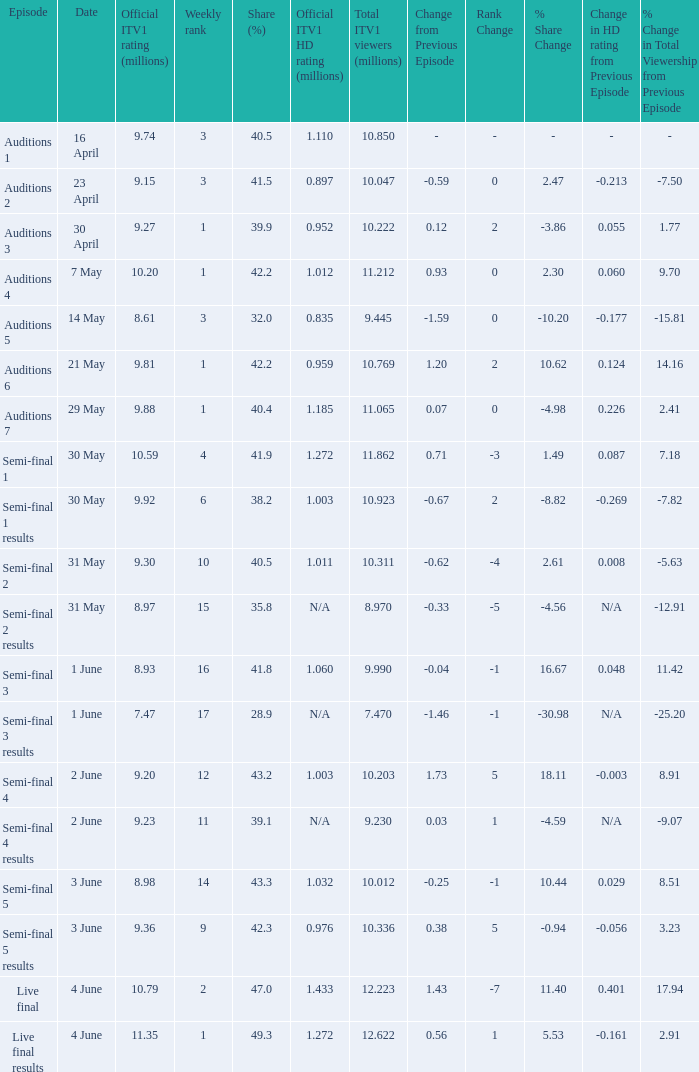What was the portion (%) for the semi-final 2 episode? 40.5. 